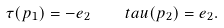<formula> <loc_0><loc_0><loc_500><loc_500>\tau ( p _ { 1 } ) = - e _ { 2 } \quad t a u ( p _ { 2 } ) = e _ { 2 } .</formula> 